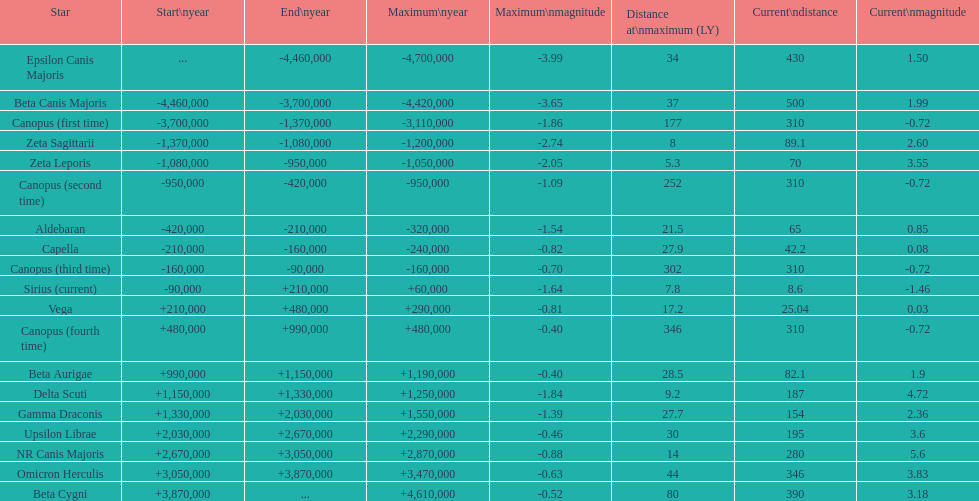What is the unique star with a distance not exceeding 80? Beta Cygni. 